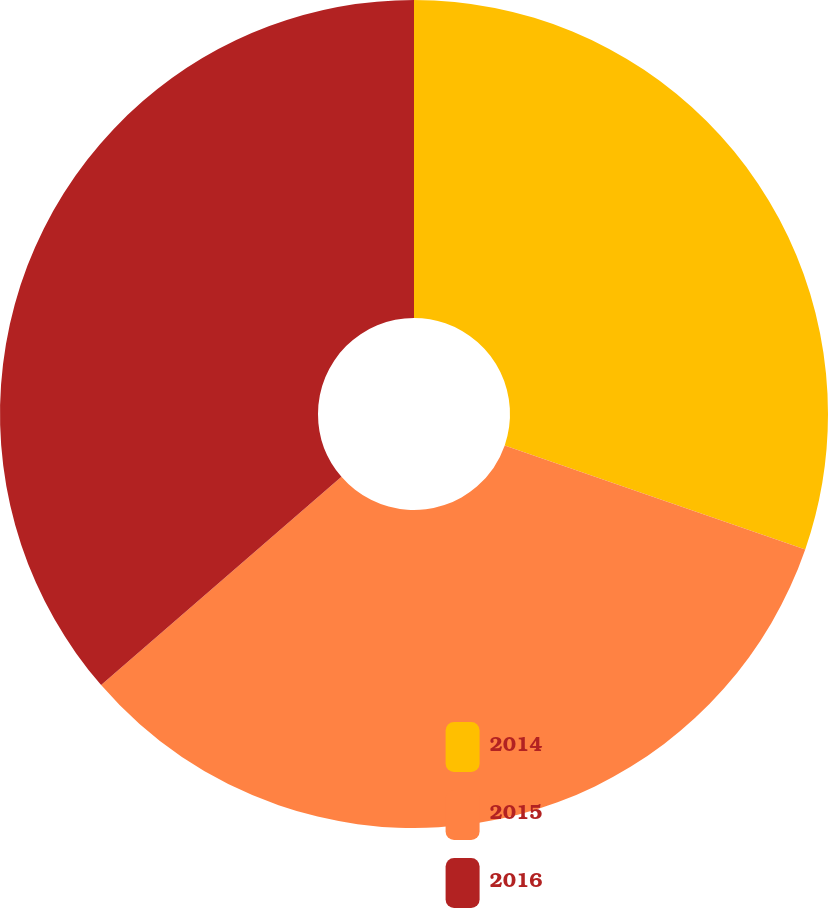Convert chart. <chart><loc_0><loc_0><loc_500><loc_500><pie_chart><fcel>2014<fcel>2015<fcel>2016<nl><fcel>30.3%<fcel>33.33%<fcel>36.36%<nl></chart> 